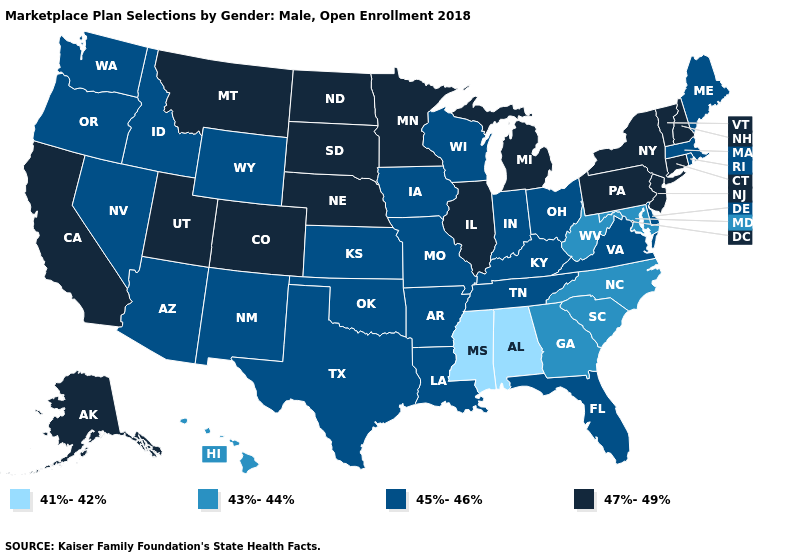Which states have the highest value in the USA?
Keep it brief. Alaska, California, Colorado, Connecticut, Illinois, Michigan, Minnesota, Montana, Nebraska, New Hampshire, New Jersey, New York, North Dakota, Pennsylvania, South Dakota, Utah, Vermont. What is the value of Florida?
Short answer required. 45%-46%. Does Massachusetts have a lower value than New Jersey?
Answer briefly. Yes. Name the states that have a value in the range 45%-46%?
Give a very brief answer. Arizona, Arkansas, Delaware, Florida, Idaho, Indiana, Iowa, Kansas, Kentucky, Louisiana, Maine, Massachusetts, Missouri, Nevada, New Mexico, Ohio, Oklahoma, Oregon, Rhode Island, Tennessee, Texas, Virginia, Washington, Wisconsin, Wyoming. Does Mississippi have the lowest value in the USA?
Answer briefly. Yes. Does New York have the highest value in the USA?
Short answer required. Yes. What is the value of Maryland?
Quick response, please. 43%-44%. What is the value of Hawaii?
Keep it brief. 43%-44%. What is the value of Connecticut?
Write a very short answer. 47%-49%. Does Iowa have the highest value in the USA?
Short answer required. No. What is the highest value in the Northeast ?
Be succinct. 47%-49%. Name the states that have a value in the range 47%-49%?
Answer briefly. Alaska, California, Colorado, Connecticut, Illinois, Michigan, Minnesota, Montana, Nebraska, New Hampshire, New Jersey, New York, North Dakota, Pennsylvania, South Dakota, Utah, Vermont. What is the highest value in the Northeast ?
Give a very brief answer. 47%-49%. What is the value of Massachusetts?
Short answer required. 45%-46%. What is the highest value in the MidWest ?
Short answer required. 47%-49%. 